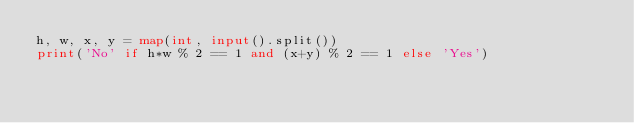Convert code to text. <code><loc_0><loc_0><loc_500><loc_500><_Python_>h, w, x, y = map(int, input().split())
print('No' if h*w % 2 == 1 and (x+y) % 2 == 1 else 'Yes')
</code> 